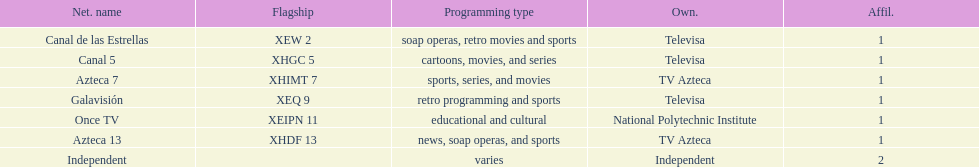Who is the only network possessor featured in a consecutive sequence in the chart? Televisa. 